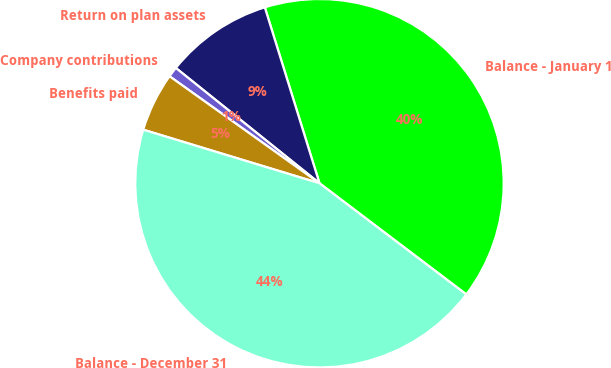<chart> <loc_0><loc_0><loc_500><loc_500><pie_chart><fcel>Balance - January 1<fcel>Return on plan assets<fcel>Company contributions<fcel>Benefits paid<fcel>Balance - December 31<nl><fcel>40.11%<fcel>9.44%<fcel>0.9%<fcel>5.17%<fcel>44.38%<nl></chart> 